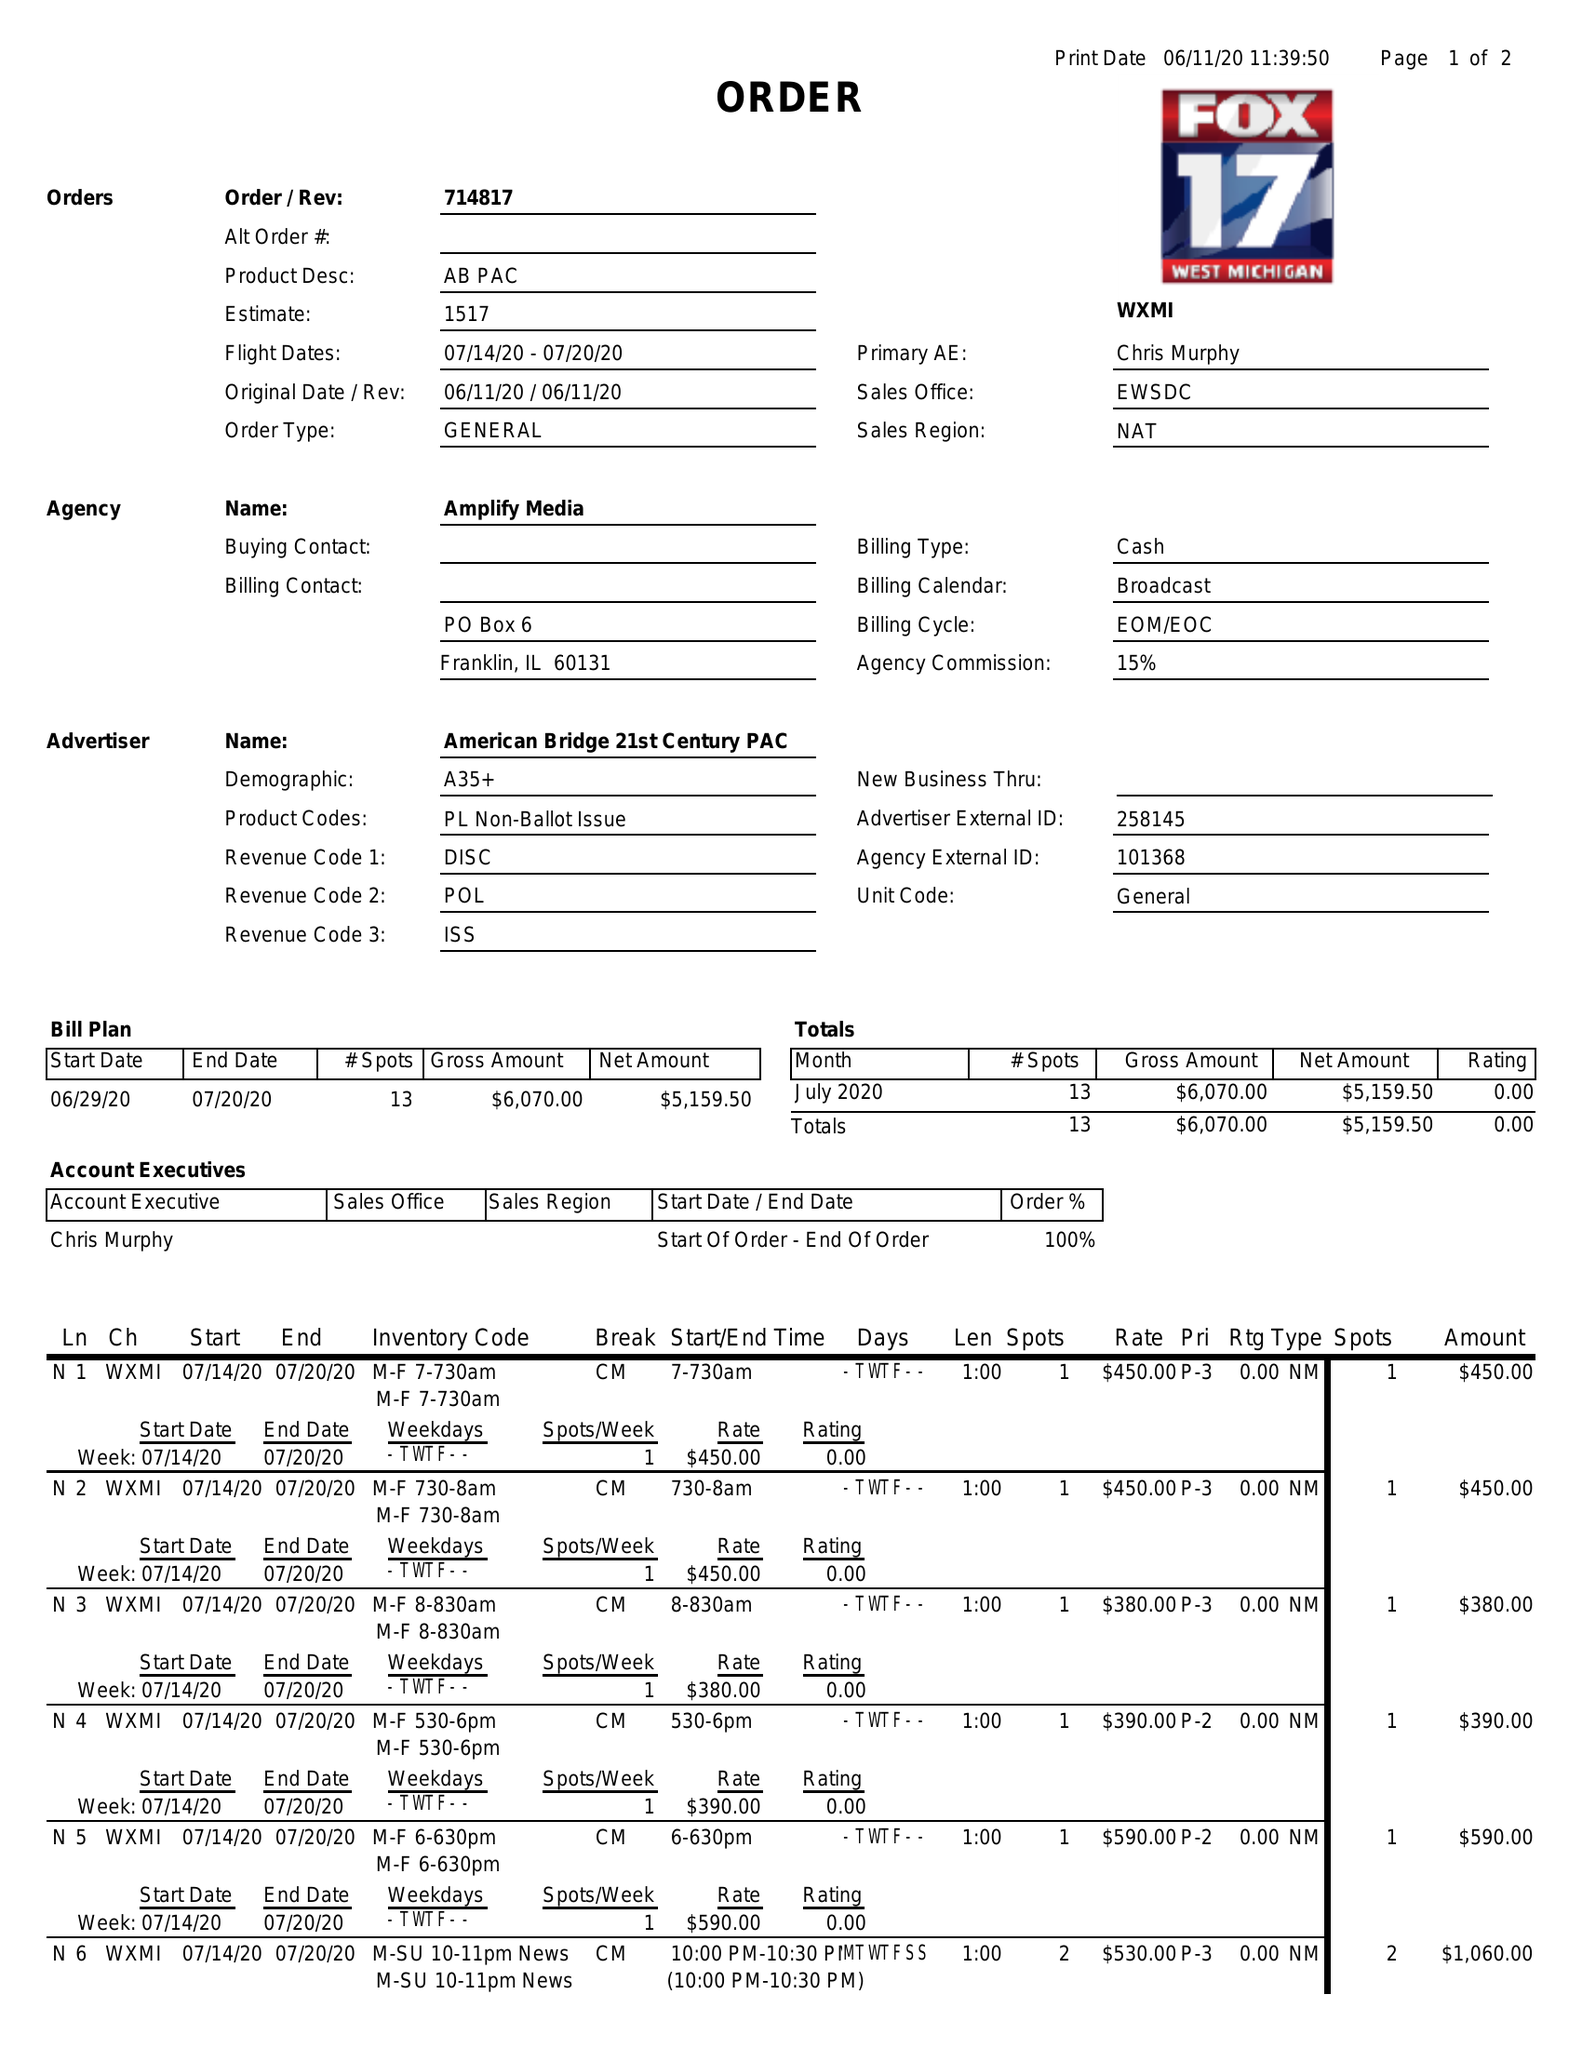What is the value for the flight_from?
Answer the question using a single word or phrase. 07/14/20 